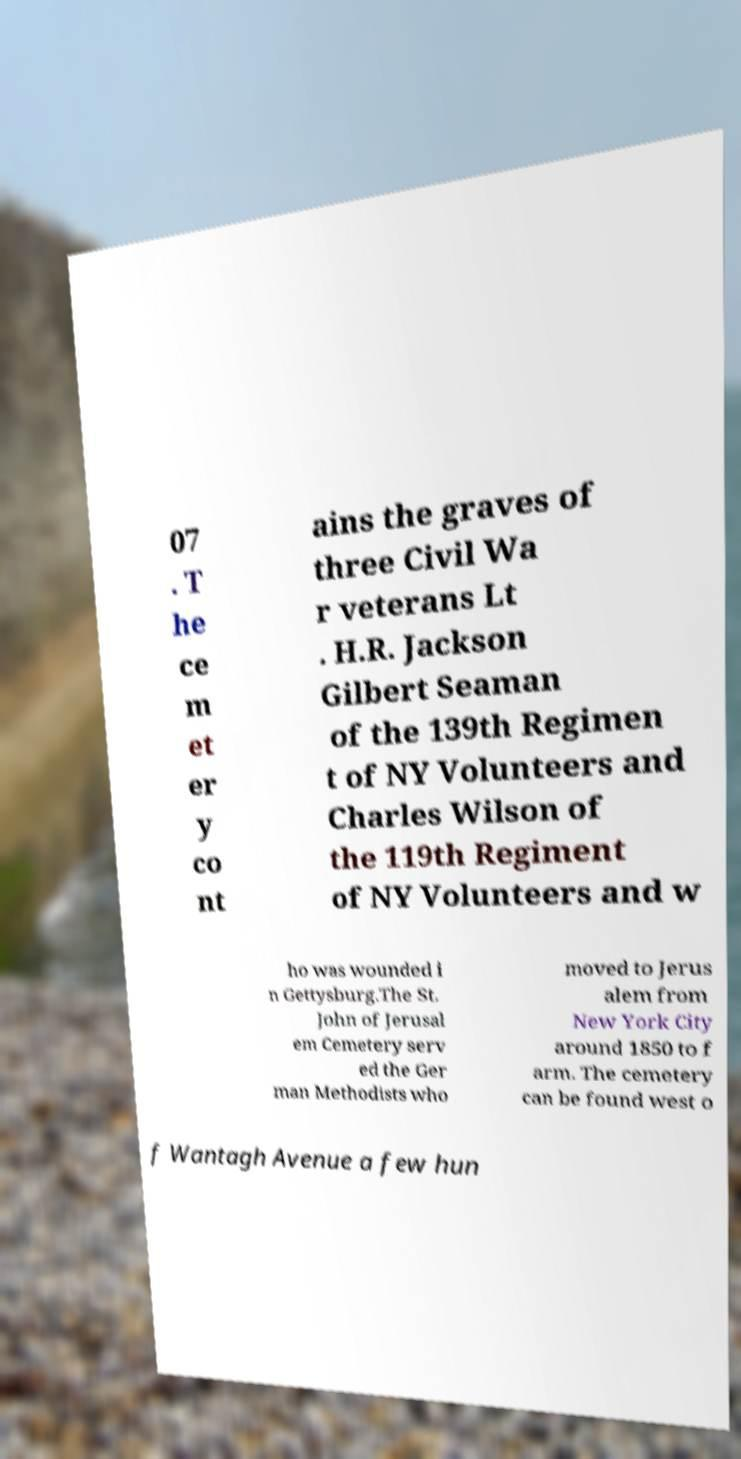What messages or text are displayed in this image? I need them in a readable, typed format. 07 . T he ce m et er y co nt ains the graves of three Civil Wa r veterans Lt . H.R. Jackson Gilbert Seaman of the 139th Regimen t of NY Volunteers and Charles Wilson of the 119th Regiment of NY Volunteers and w ho was wounded i n Gettysburg.The St. John of Jerusal em Cemetery serv ed the Ger man Methodists who moved to Jerus alem from New York City around 1850 to f arm. The cemetery can be found west o f Wantagh Avenue a few hun 